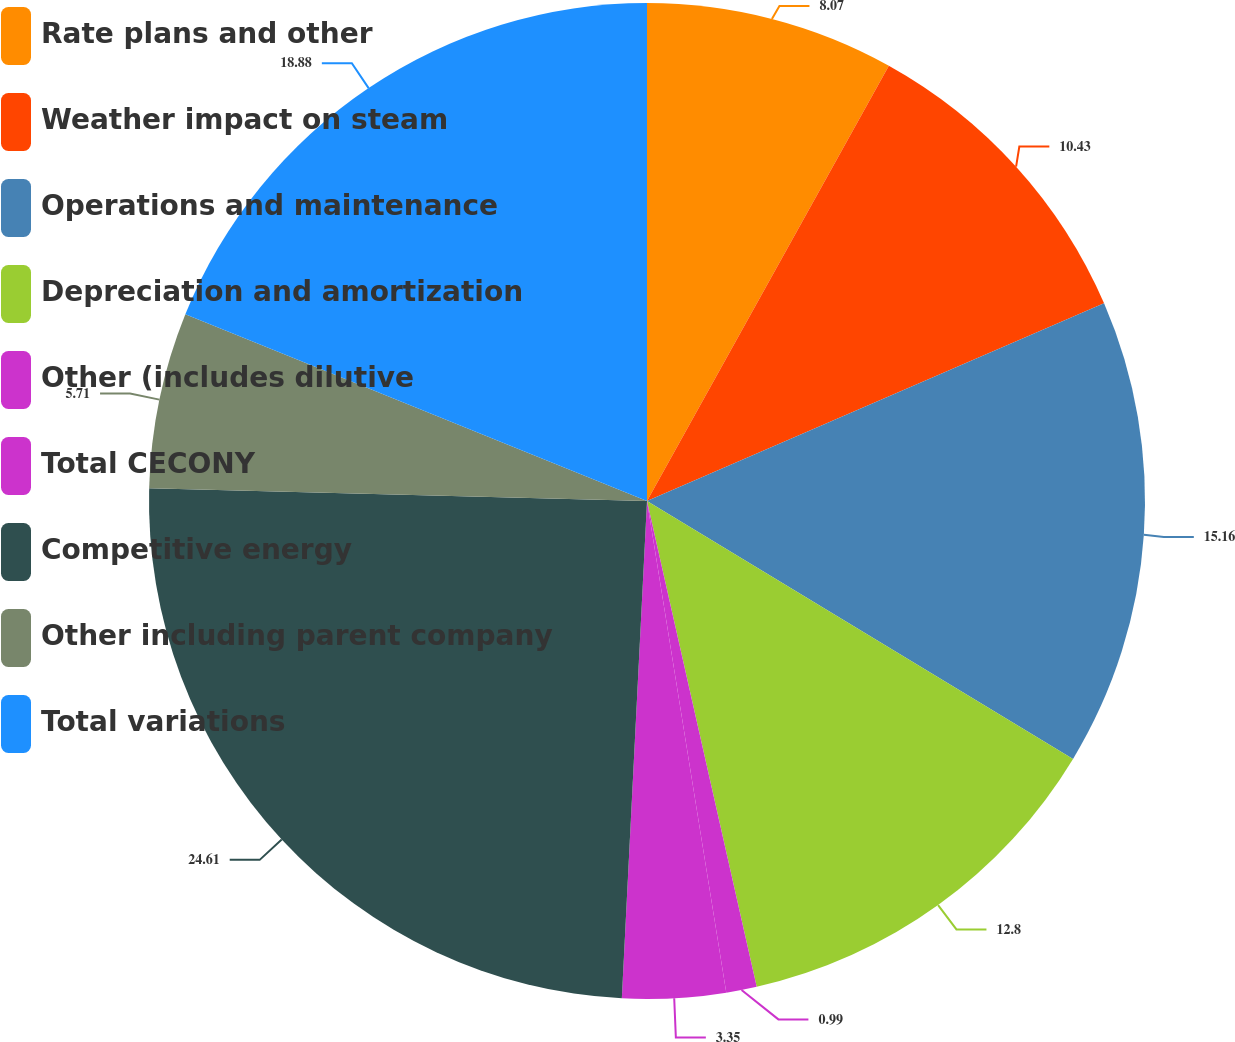Convert chart to OTSL. <chart><loc_0><loc_0><loc_500><loc_500><pie_chart><fcel>Rate plans and other<fcel>Weather impact on steam<fcel>Operations and maintenance<fcel>Depreciation and amortization<fcel>Other (includes dilutive<fcel>Total CECONY<fcel>Competitive energy<fcel>Other including parent company<fcel>Total variations<nl><fcel>8.07%<fcel>10.43%<fcel>15.16%<fcel>12.8%<fcel>0.99%<fcel>3.35%<fcel>24.6%<fcel>5.71%<fcel>18.88%<nl></chart> 